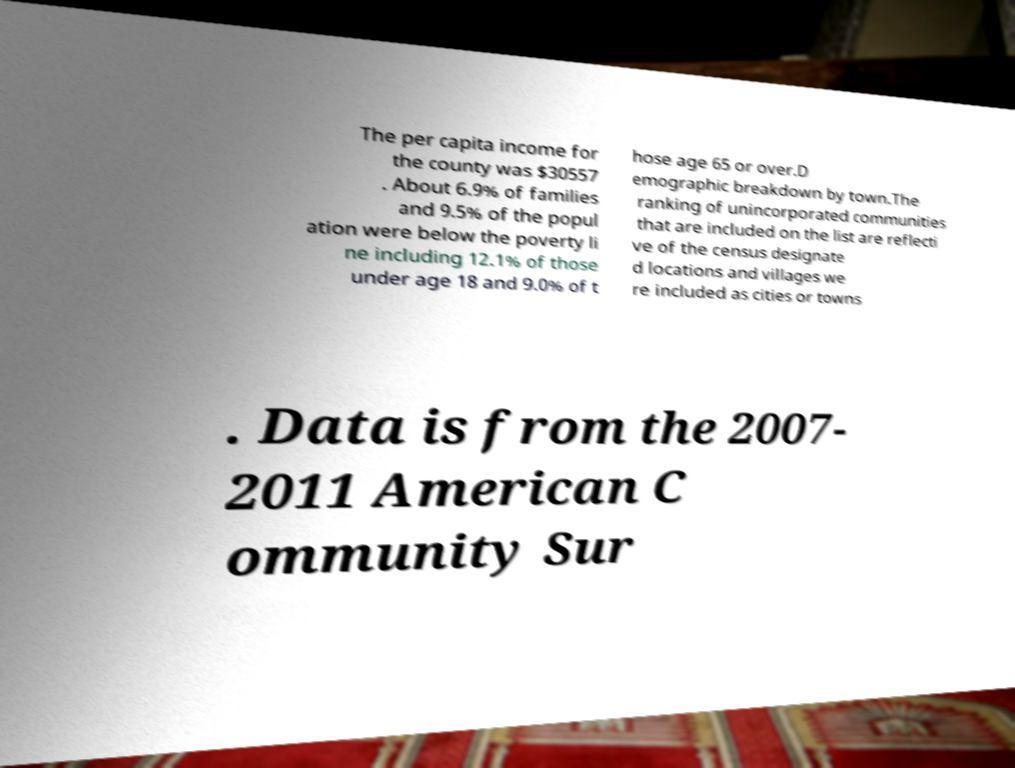Please identify and transcribe the text found in this image. The per capita income for the county was $30557 . About 6.9% of families and 9.5% of the popul ation were below the poverty li ne including 12.1% of those under age 18 and 9.0% of t hose age 65 or over.D emographic breakdown by town.The ranking of unincorporated communities that are included on the list are reflecti ve of the census designate d locations and villages we re included as cities or towns . Data is from the 2007- 2011 American C ommunity Sur 